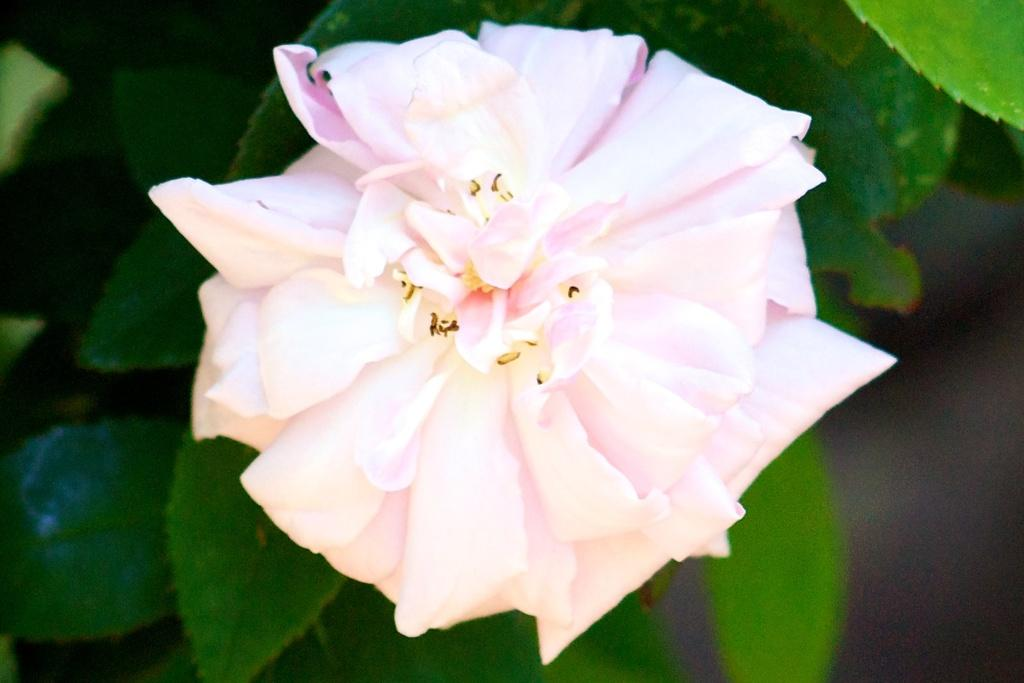What is the main subject of the image? There is a flower in the image. What other plant elements can be seen in the image? There are leaves in the image. Can you describe the background of the image? The background of the image is blurred. What type of print can be seen on the flower in the image? There is no print visible on the flower in the image. Can you tell me how many planets are visible in the background of the image? There are no planets visible in the image, as it features a flower and leaves with a blurred background. 